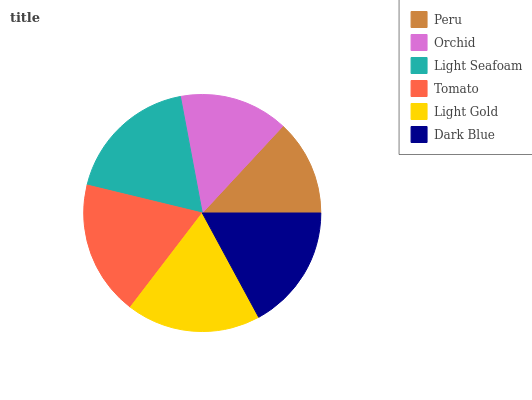Is Peru the minimum?
Answer yes or no. Yes. Is Tomato the maximum?
Answer yes or no. Yes. Is Orchid the minimum?
Answer yes or no. No. Is Orchid the maximum?
Answer yes or no. No. Is Orchid greater than Peru?
Answer yes or no. Yes. Is Peru less than Orchid?
Answer yes or no. Yes. Is Peru greater than Orchid?
Answer yes or no. No. Is Orchid less than Peru?
Answer yes or no. No. Is Light Seafoam the high median?
Answer yes or no. Yes. Is Dark Blue the low median?
Answer yes or no. Yes. Is Peru the high median?
Answer yes or no. No. Is Tomato the low median?
Answer yes or no. No. 